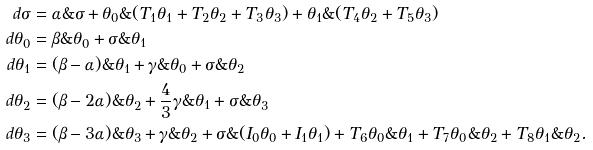Convert formula to latex. <formula><loc_0><loc_0><loc_500><loc_500>d \sigma & = \alpha \& \sigma + \theta _ { 0 } \& ( T _ { 1 } \theta _ { 1 } + T _ { 2 } \theta _ { 2 } + T _ { 3 } \theta _ { 3 } ) + \theta _ { 1 } \& ( T _ { 4 } \theta _ { 2 } + T _ { 5 } \theta _ { 3 } ) \\ d \theta _ { 0 } & = \beta \& \theta _ { 0 } + \sigma \& \theta _ { 1 } \\ d \theta _ { 1 } & = ( \beta - \alpha ) \& \theta _ { 1 } + \gamma \& \theta _ { 0 } + \sigma \& \theta _ { 2 } \\ d \theta _ { 2 } & = ( \beta - 2 \alpha ) \& \theta _ { 2 } + \frac { 4 } { 3 } \gamma \& \theta _ { 1 } + \sigma \& \theta _ { 3 } \\ d \theta _ { 3 } & = ( \beta - 3 \alpha ) \& \theta _ { 3 } + \gamma \& \theta _ { 2 } + \sigma \& ( I _ { 0 } \theta _ { 0 } + I _ { 1 } \theta _ { 1 } ) + T _ { 6 } \theta _ { 0 } \& \theta _ { 1 } + T _ { 7 } \theta _ { 0 } \& \theta _ { 2 } + T _ { 8 } \theta _ { 1 } \& \theta _ { 2 } .</formula> 